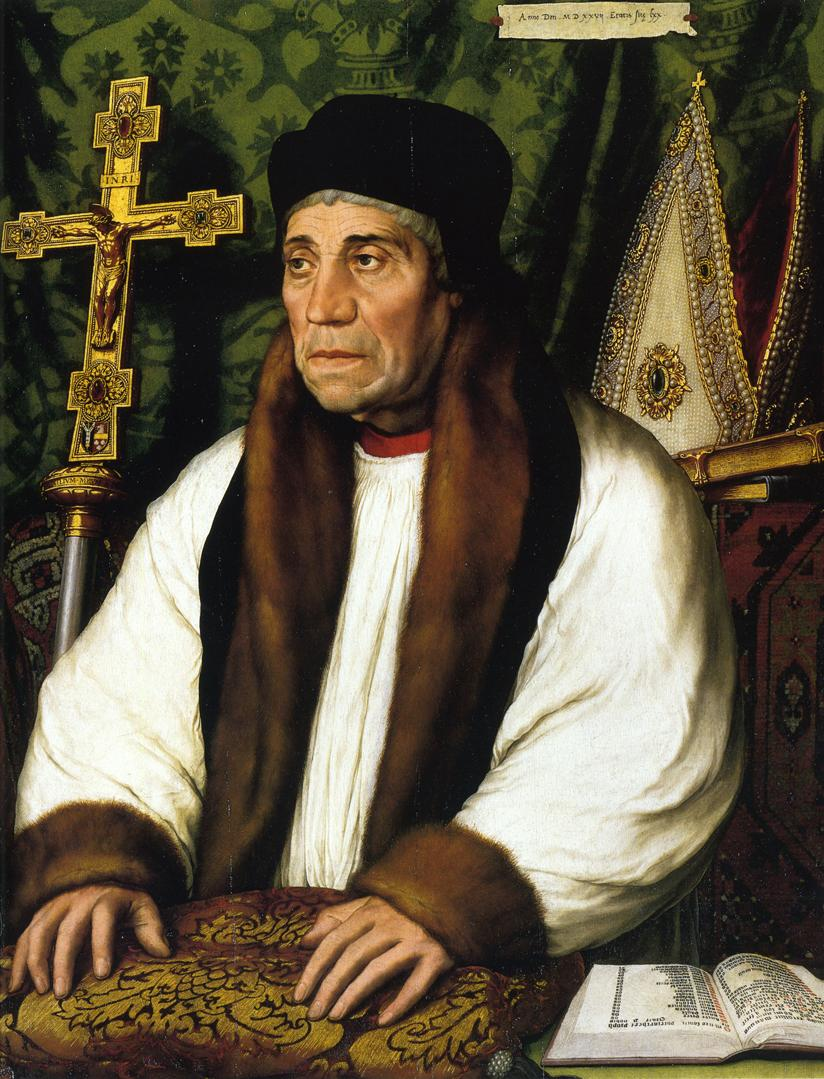Think of a title for this artwork. The Scholar of Sacred Wisdom How does the fur stole contribute to the portrayal of the man? The fur stole adds an element of luxury and distinction to the man's appearance. Such opulent clothing would not be common and signifies his high status and the respect he commands. It also emphasizes the seriousness with which the artist intended to portray the subject, underscoring the prestige and authority he likely held in his religious or scholarly community. 